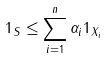Convert formula to latex. <formula><loc_0><loc_0><loc_500><loc_500>1 _ { S } \leq \sum _ { i = 1 } ^ { n } \alpha _ { i } 1 _ { X _ { i } }</formula> 